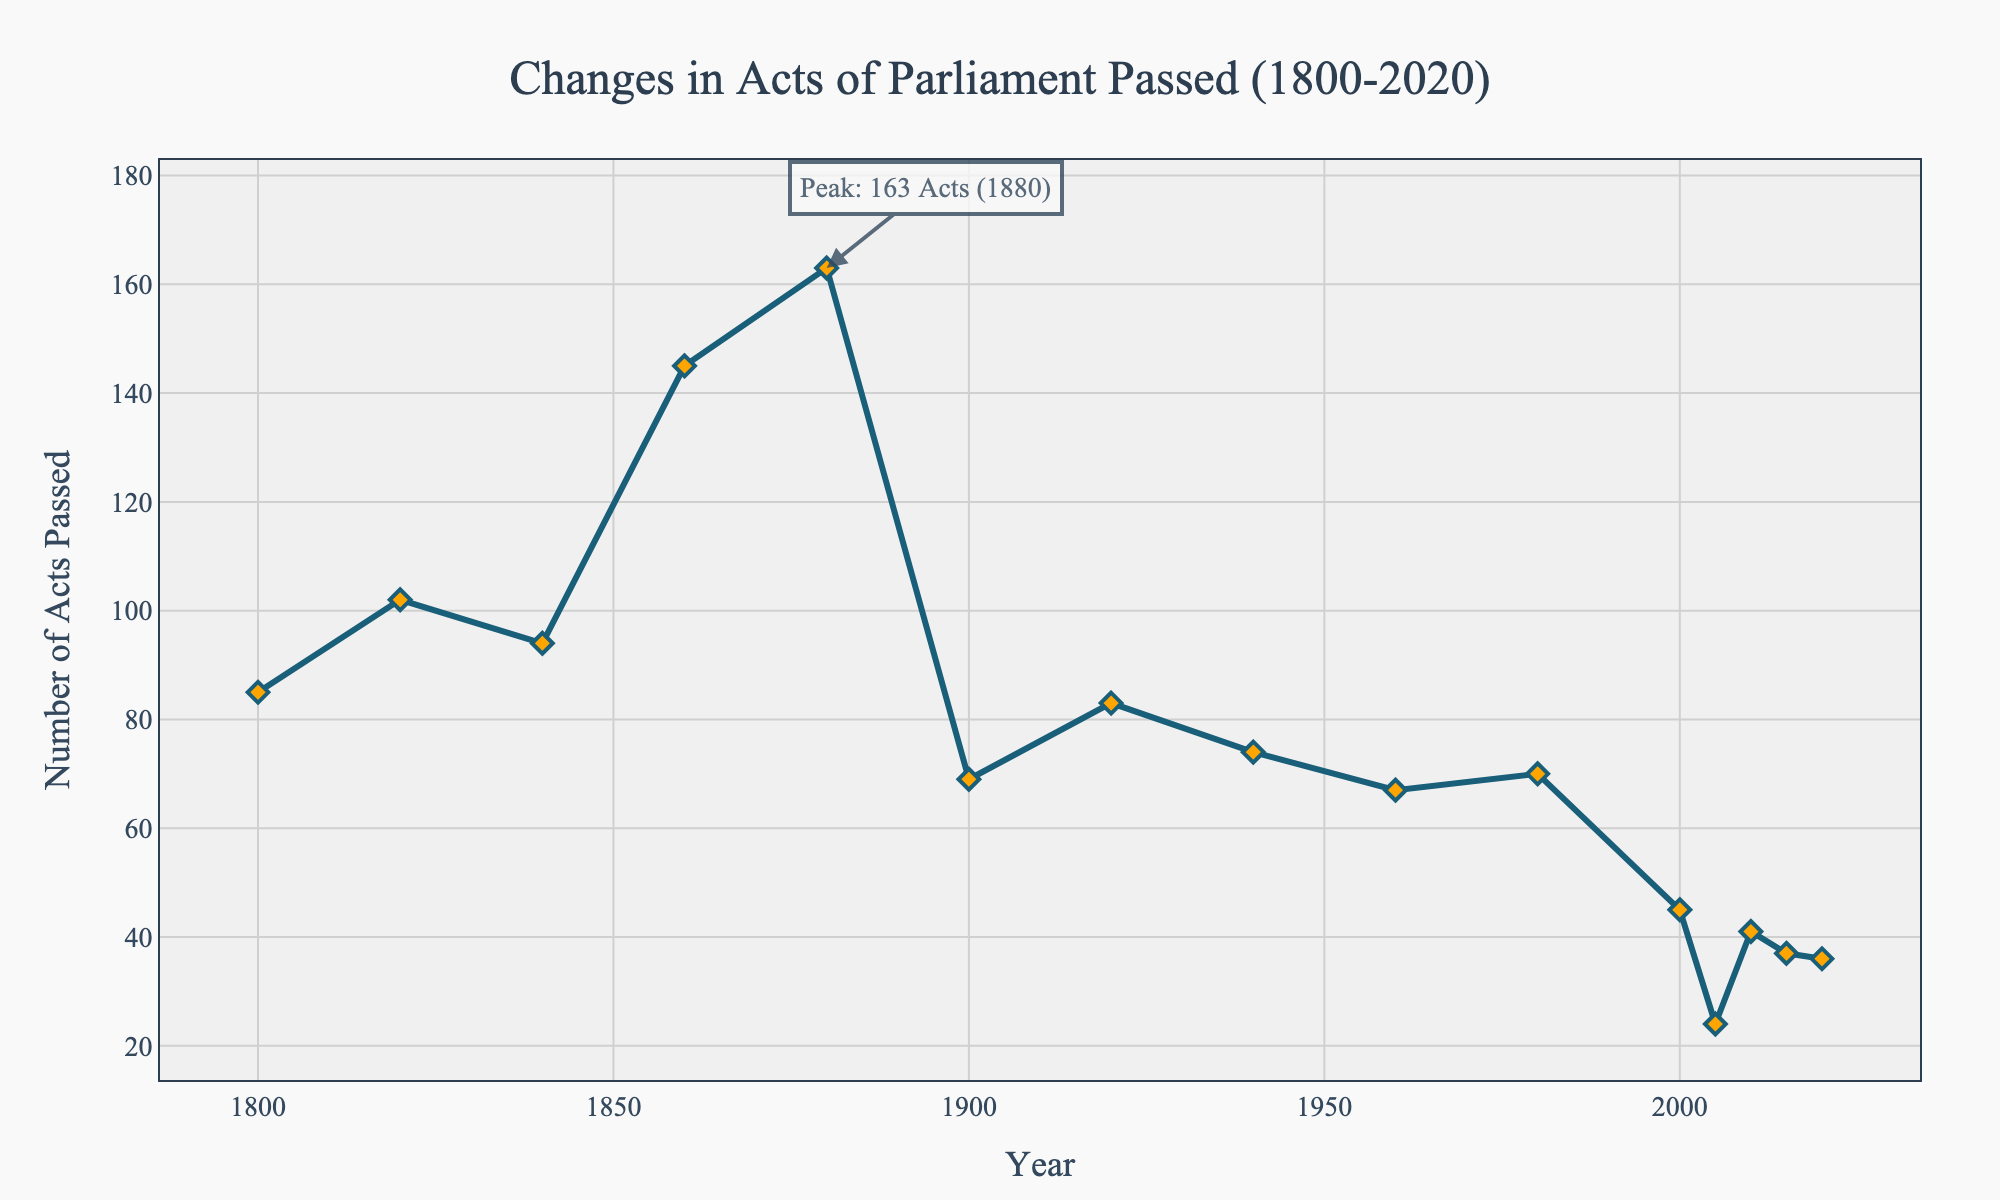What is the peak number of Acts passed in a single year, and in what year did it happen? To determine the peak number of Acts, look for the highest point on the line chart and note the corresponding year. The peak, marked by an annotation, is 163 Acts in 1880.
Answer: 163 Acts, 1880 How many Acts of Parliament were passed in 2000 compared to 2010? Compare the number of Acts passed by referencing the data points for the years 2000 and 2010. In 2000, 45 Acts were passed, and in 2010, 41 Acts were passed.
Answer: 45 in 2000, 41 in 2010 By how much did the number of Acts passed change from 1880 to 1900? Calculate the difference in the number of Acts passed between 1880 and 1900 by subtracting the number in 1900 from the number in 1880 (163 - 69).
Answer: Decrease of 94 What trend is observable in the number of Acts passed between 1800 and 2020? Generally observe the slope of the line from 1800 onwards. There is fluctuation, but a noticeable declining trend from the 19th century to the 21st century.
Answer: Declining trend How does the number of Acts passed in 1960 compare to the number of Acts passed in 1980? Compare the values for the years 1960 and 1980. In 1960, 67 Acts were passed, and in 1980, 70 Acts were passed.
Answer: Slightly more in 1980 (70) than in 1960 (67) What was the number of Acts passed in 1940 and 1940? Reference the data points for the years 1940 and 1940. For 1940, 74 Acts were passed.
Answer: 74 What is the average number of Acts passed annually between 1800 and 1880? Sum the values for the years 1800, 1820, 1840, 1860, and 1880, then divide by the number of years (85 + 102 + 94 + 145 + 163 = 589; 589/5).
Answer: 117.8 Acts Which decade saw the lowest number of Acts of Parliament passed, and what was the number? Identify the decade with the lowest recorded data point. The 2005-2010 period saw the lowest, with 24 Acts passed in 2005.
Answer: 2005-2010, 24 Acts How many Acts were passed in total between 1900 and 2000? Sum the values for the years 1900, 1920, 1940, 1960, 1980, and 2000. (69 + 83 + 74 + 67 + 70 + 45 = 408).
Answer: 408 Acts 